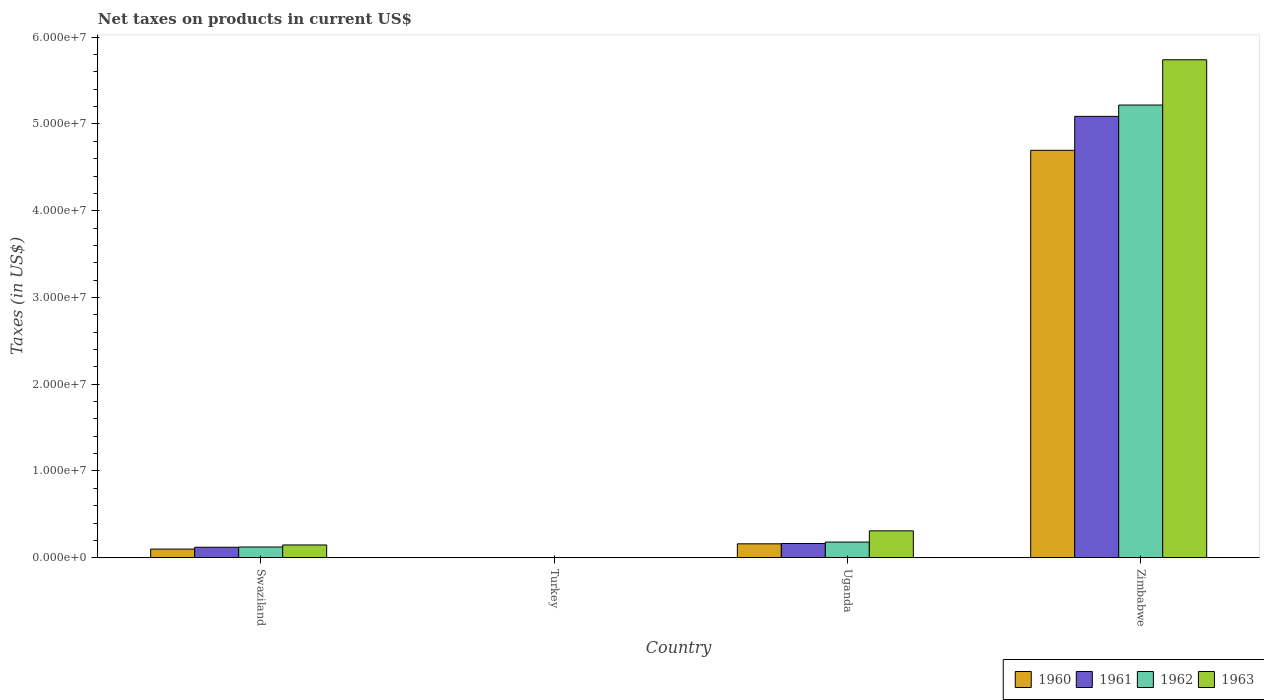How many different coloured bars are there?
Provide a succinct answer. 4. How many bars are there on the 1st tick from the right?
Make the answer very short. 4. What is the label of the 4th group of bars from the left?
Ensure brevity in your answer.  Zimbabwe. What is the net taxes on products in 1960 in Swaziland?
Give a very brief answer. 1.00e+06. Across all countries, what is the maximum net taxes on products in 1961?
Provide a succinct answer. 5.09e+07. Across all countries, what is the minimum net taxes on products in 1962?
Provide a short and direct response. 1600. In which country was the net taxes on products in 1961 maximum?
Give a very brief answer. Zimbabwe. What is the total net taxes on products in 1961 in the graph?
Offer a very short reply. 5.37e+07. What is the difference between the net taxes on products in 1960 in Swaziland and that in Uganda?
Your answer should be compact. -6.03e+05. What is the difference between the net taxes on products in 1962 in Swaziland and the net taxes on products in 1963 in Zimbabwe?
Your answer should be very brief. -5.62e+07. What is the average net taxes on products in 1960 per country?
Offer a terse response. 1.24e+07. What is the difference between the net taxes on products of/in 1960 and net taxes on products of/in 1963 in Zimbabwe?
Your answer should be compact. -1.04e+07. What is the ratio of the net taxes on products in 1961 in Uganda to that in Zimbabwe?
Make the answer very short. 0.03. What is the difference between the highest and the second highest net taxes on products in 1961?
Ensure brevity in your answer.  -4.34e+05. What is the difference between the highest and the lowest net taxes on products in 1960?
Give a very brief answer. 4.70e+07. In how many countries, is the net taxes on products in 1962 greater than the average net taxes on products in 1962 taken over all countries?
Your answer should be compact. 1. Is it the case that in every country, the sum of the net taxes on products in 1962 and net taxes on products in 1961 is greater than the sum of net taxes on products in 1963 and net taxes on products in 1960?
Offer a terse response. No. What does the 4th bar from the left in Turkey represents?
Keep it short and to the point. 1963. Is it the case that in every country, the sum of the net taxes on products in 1963 and net taxes on products in 1962 is greater than the net taxes on products in 1961?
Ensure brevity in your answer.  Yes. How many bars are there?
Provide a short and direct response. 16. How many countries are there in the graph?
Offer a very short reply. 4. What is the difference between two consecutive major ticks on the Y-axis?
Make the answer very short. 1.00e+07. Does the graph contain any zero values?
Your response must be concise. No. How many legend labels are there?
Provide a short and direct response. 4. What is the title of the graph?
Offer a terse response. Net taxes on products in current US$. Does "1997" appear as one of the legend labels in the graph?
Offer a terse response. No. What is the label or title of the Y-axis?
Your answer should be very brief. Taxes (in US$). What is the Taxes (in US$) in 1960 in Swaziland?
Your answer should be very brief. 1.00e+06. What is the Taxes (in US$) in 1961 in Swaziland?
Provide a succinct answer. 1.21e+06. What is the Taxes (in US$) of 1962 in Swaziland?
Your response must be concise. 1.24e+06. What is the Taxes (in US$) in 1963 in Swaziland?
Give a very brief answer. 1.47e+06. What is the Taxes (in US$) in 1960 in Turkey?
Make the answer very short. 1300. What is the Taxes (in US$) of 1961 in Turkey?
Provide a short and direct response. 1500. What is the Taxes (in US$) in 1962 in Turkey?
Provide a short and direct response. 1600. What is the Taxes (in US$) in 1963 in Turkey?
Keep it short and to the point. 1800. What is the Taxes (in US$) in 1960 in Uganda?
Make the answer very short. 1.61e+06. What is the Taxes (in US$) of 1961 in Uganda?
Your answer should be compact. 1.64e+06. What is the Taxes (in US$) in 1962 in Uganda?
Keep it short and to the point. 1.81e+06. What is the Taxes (in US$) in 1963 in Uganda?
Make the answer very short. 3.10e+06. What is the Taxes (in US$) in 1960 in Zimbabwe?
Offer a very short reply. 4.70e+07. What is the Taxes (in US$) of 1961 in Zimbabwe?
Your response must be concise. 5.09e+07. What is the Taxes (in US$) of 1962 in Zimbabwe?
Keep it short and to the point. 5.22e+07. What is the Taxes (in US$) in 1963 in Zimbabwe?
Your response must be concise. 5.74e+07. Across all countries, what is the maximum Taxes (in US$) in 1960?
Your response must be concise. 4.70e+07. Across all countries, what is the maximum Taxes (in US$) in 1961?
Keep it short and to the point. 5.09e+07. Across all countries, what is the maximum Taxes (in US$) in 1962?
Make the answer very short. 5.22e+07. Across all countries, what is the maximum Taxes (in US$) in 1963?
Provide a short and direct response. 5.74e+07. Across all countries, what is the minimum Taxes (in US$) of 1960?
Make the answer very short. 1300. Across all countries, what is the minimum Taxes (in US$) in 1961?
Provide a short and direct response. 1500. Across all countries, what is the minimum Taxes (in US$) of 1962?
Ensure brevity in your answer.  1600. Across all countries, what is the minimum Taxes (in US$) in 1963?
Offer a terse response. 1800. What is the total Taxes (in US$) of 1960 in the graph?
Keep it short and to the point. 4.96e+07. What is the total Taxes (in US$) of 1961 in the graph?
Ensure brevity in your answer.  5.37e+07. What is the total Taxes (in US$) in 1962 in the graph?
Offer a terse response. 5.52e+07. What is the total Taxes (in US$) of 1963 in the graph?
Make the answer very short. 6.20e+07. What is the difference between the Taxes (in US$) of 1960 in Swaziland and that in Turkey?
Give a very brief answer. 1.00e+06. What is the difference between the Taxes (in US$) of 1961 in Swaziland and that in Turkey?
Keep it short and to the point. 1.21e+06. What is the difference between the Taxes (in US$) of 1962 in Swaziland and that in Turkey?
Offer a terse response. 1.24e+06. What is the difference between the Taxes (in US$) in 1963 in Swaziland and that in Turkey?
Provide a short and direct response. 1.47e+06. What is the difference between the Taxes (in US$) of 1960 in Swaziland and that in Uganda?
Your answer should be compact. -6.03e+05. What is the difference between the Taxes (in US$) of 1961 in Swaziland and that in Uganda?
Provide a short and direct response. -4.34e+05. What is the difference between the Taxes (in US$) in 1962 in Swaziland and that in Uganda?
Provide a succinct answer. -5.69e+05. What is the difference between the Taxes (in US$) of 1963 in Swaziland and that in Uganda?
Give a very brief answer. -1.63e+06. What is the difference between the Taxes (in US$) in 1960 in Swaziland and that in Zimbabwe?
Ensure brevity in your answer.  -4.60e+07. What is the difference between the Taxes (in US$) of 1961 in Swaziland and that in Zimbabwe?
Your answer should be compact. -4.97e+07. What is the difference between the Taxes (in US$) of 1962 in Swaziland and that in Zimbabwe?
Your answer should be very brief. -5.09e+07. What is the difference between the Taxes (in US$) in 1963 in Swaziland and that in Zimbabwe?
Give a very brief answer. -5.59e+07. What is the difference between the Taxes (in US$) in 1960 in Turkey and that in Uganda?
Offer a very short reply. -1.60e+06. What is the difference between the Taxes (in US$) in 1961 in Turkey and that in Uganda?
Your answer should be very brief. -1.64e+06. What is the difference between the Taxes (in US$) in 1962 in Turkey and that in Uganda?
Your response must be concise. -1.81e+06. What is the difference between the Taxes (in US$) of 1963 in Turkey and that in Uganda?
Provide a succinct answer. -3.10e+06. What is the difference between the Taxes (in US$) in 1960 in Turkey and that in Zimbabwe?
Provide a succinct answer. -4.70e+07. What is the difference between the Taxes (in US$) of 1961 in Turkey and that in Zimbabwe?
Your answer should be compact. -5.09e+07. What is the difference between the Taxes (in US$) of 1962 in Turkey and that in Zimbabwe?
Your response must be concise. -5.22e+07. What is the difference between the Taxes (in US$) of 1963 in Turkey and that in Zimbabwe?
Give a very brief answer. -5.74e+07. What is the difference between the Taxes (in US$) of 1960 in Uganda and that in Zimbabwe?
Your response must be concise. -4.54e+07. What is the difference between the Taxes (in US$) of 1961 in Uganda and that in Zimbabwe?
Your answer should be compact. -4.92e+07. What is the difference between the Taxes (in US$) in 1962 in Uganda and that in Zimbabwe?
Your response must be concise. -5.04e+07. What is the difference between the Taxes (in US$) of 1963 in Uganda and that in Zimbabwe?
Make the answer very short. -5.43e+07. What is the difference between the Taxes (in US$) of 1960 in Swaziland and the Taxes (in US$) of 1961 in Turkey?
Your answer should be compact. 1.00e+06. What is the difference between the Taxes (in US$) in 1960 in Swaziland and the Taxes (in US$) in 1962 in Turkey?
Provide a succinct answer. 1.00e+06. What is the difference between the Taxes (in US$) in 1960 in Swaziland and the Taxes (in US$) in 1963 in Turkey?
Make the answer very short. 1.00e+06. What is the difference between the Taxes (in US$) of 1961 in Swaziland and the Taxes (in US$) of 1962 in Turkey?
Your response must be concise. 1.21e+06. What is the difference between the Taxes (in US$) of 1961 in Swaziland and the Taxes (in US$) of 1963 in Turkey?
Ensure brevity in your answer.  1.21e+06. What is the difference between the Taxes (in US$) of 1962 in Swaziland and the Taxes (in US$) of 1963 in Turkey?
Your response must be concise. 1.24e+06. What is the difference between the Taxes (in US$) of 1960 in Swaziland and the Taxes (in US$) of 1961 in Uganda?
Provide a succinct answer. -6.40e+05. What is the difference between the Taxes (in US$) of 1960 in Swaziland and the Taxes (in US$) of 1962 in Uganda?
Your answer should be compact. -8.05e+05. What is the difference between the Taxes (in US$) in 1960 in Swaziland and the Taxes (in US$) in 1963 in Uganda?
Provide a succinct answer. -2.10e+06. What is the difference between the Taxes (in US$) in 1961 in Swaziland and the Taxes (in US$) in 1962 in Uganda?
Ensure brevity in your answer.  -5.99e+05. What is the difference between the Taxes (in US$) of 1961 in Swaziland and the Taxes (in US$) of 1963 in Uganda?
Your response must be concise. -1.89e+06. What is the difference between the Taxes (in US$) in 1962 in Swaziland and the Taxes (in US$) in 1963 in Uganda?
Ensure brevity in your answer.  -1.86e+06. What is the difference between the Taxes (in US$) in 1960 in Swaziland and the Taxes (in US$) in 1961 in Zimbabwe?
Your answer should be very brief. -4.99e+07. What is the difference between the Taxes (in US$) in 1960 in Swaziland and the Taxes (in US$) in 1962 in Zimbabwe?
Keep it short and to the point. -5.12e+07. What is the difference between the Taxes (in US$) of 1960 in Swaziland and the Taxes (in US$) of 1963 in Zimbabwe?
Make the answer very short. -5.64e+07. What is the difference between the Taxes (in US$) of 1961 in Swaziland and the Taxes (in US$) of 1962 in Zimbabwe?
Ensure brevity in your answer.  -5.10e+07. What is the difference between the Taxes (in US$) in 1961 in Swaziland and the Taxes (in US$) in 1963 in Zimbabwe?
Your response must be concise. -5.62e+07. What is the difference between the Taxes (in US$) in 1962 in Swaziland and the Taxes (in US$) in 1963 in Zimbabwe?
Ensure brevity in your answer.  -5.62e+07. What is the difference between the Taxes (in US$) of 1960 in Turkey and the Taxes (in US$) of 1961 in Uganda?
Give a very brief answer. -1.64e+06. What is the difference between the Taxes (in US$) of 1960 in Turkey and the Taxes (in US$) of 1962 in Uganda?
Your response must be concise. -1.81e+06. What is the difference between the Taxes (in US$) in 1960 in Turkey and the Taxes (in US$) in 1963 in Uganda?
Give a very brief answer. -3.10e+06. What is the difference between the Taxes (in US$) of 1961 in Turkey and the Taxes (in US$) of 1962 in Uganda?
Offer a terse response. -1.81e+06. What is the difference between the Taxes (in US$) of 1961 in Turkey and the Taxes (in US$) of 1963 in Uganda?
Your answer should be very brief. -3.10e+06. What is the difference between the Taxes (in US$) in 1962 in Turkey and the Taxes (in US$) in 1963 in Uganda?
Provide a succinct answer. -3.10e+06. What is the difference between the Taxes (in US$) of 1960 in Turkey and the Taxes (in US$) of 1961 in Zimbabwe?
Make the answer very short. -5.09e+07. What is the difference between the Taxes (in US$) of 1960 in Turkey and the Taxes (in US$) of 1962 in Zimbabwe?
Make the answer very short. -5.22e+07. What is the difference between the Taxes (in US$) of 1960 in Turkey and the Taxes (in US$) of 1963 in Zimbabwe?
Make the answer very short. -5.74e+07. What is the difference between the Taxes (in US$) of 1961 in Turkey and the Taxes (in US$) of 1962 in Zimbabwe?
Your answer should be very brief. -5.22e+07. What is the difference between the Taxes (in US$) of 1961 in Turkey and the Taxes (in US$) of 1963 in Zimbabwe?
Offer a terse response. -5.74e+07. What is the difference between the Taxes (in US$) in 1962 in Turkey and the Taxes (in US$) in 1963 in Zimbabwe?
Provide a short and direct response. -5.74e+07. What is the difference between the Taxes (in US$) of 1960 in Uganda and the Taxes (in US$) of 1961 in Zimbabwe?
Your response must be concise. -4.93e+07. What is the difference between the Taxes (in US$) in 1960 in Uganda and the Taxes (in US$) in 1962 in Zimbabwe?
Make the answer very short. -5.06e+07. What is the difference between the Taxes (in US$) of 1960 in Uganda and the Taxes (in US$) of 1963 in Zimbabwe?
Your answer should be very brief. -5.58e+07. What is the difference between the Taxes (in US$) in 1961 in Uganda and the Taxes (in US$) in 1962 in Zimbabwe?
Keep it short and to the point. -5.05e+07. What is the difference between the Taxes (in US$) in 1961 in Uganda and the Taxes (in US$) in 1963 in Zimbabwe?
Ensure brevity in your answer.  -5.58e+07. What is the difference between the Taxes (in US$) of 1962 in Uganda and the Taxes (in US$) of 1963 in Zimbabwe?
Provide a short and direct response. -5.56e+07. What is the average Taxes (in US$) in 1960 per country?
Give a very brief answer. 1.24e+07. What is the average Taxes (in US$) of 1961 per country?
Offer a terse response. 1.34e+07. What is the average Taxes (in US$) in 1962 per country?
Offer a terse response. 1.38e+07. What is the average Taxes (in US$) in 1963 per country?
Keep it short and to the point. 1.55e+07. What is the difference between the Taxes (in US$) in 1960 and Taxes (in US$) in 1961 in Swaziland?
Your response must be concise. -2.06e+05. What is the difference between the Taxes (in US$) in 1960 and Taxes (in US$) in 1962 in Swaziland?
Provide a succinct answer. -2.36e+05. What is the difference between the Taxes (in US$) of 1960 and Taxes (in US$) of 1963 in Swaziland?
Offer a very short reply. -4.72e+05. What is the difference between the Taxes (in US$) in 1961 and Taxes (in US$) in 1962 in Swaziland?
Offer a very short reply. -2.95e+04. What is the difference between the Taxes (in US$) of 1961 and Taxes (in US$) of 1963 in Swaziland?
Your answer should be compact. -2.65e+05. What is the difference between the Taxes (in US$) of 1962 and Taxes (in US$) of 1963 in Swaziland?
Make the answer very short. -2.36e+05. What is the difference between the Taxes (in US$) in 1960 and Taxes (in US$) in 1961 in Turkey?
Offer a terse response. -200. What is the difference between the Taxes (in US$) in 1960 and Taxes (in US$) in 1962 in Turkey?
Your answer should be compact. -300. What is the difference between the Taxes (in US$) of 1960 and Taxes (in US$) of 1963 in Turkey?
Offer a very short reply. -500. What is the difference between the Taxes (in US$) of 1961 and Taxes (in US$) of 1962 in Turkey?
Provide a short and direct response. -100. What is the difference between the Taxes (in US$) in 1961 and Taxes (in US$) in 1963 in Turkey?
Your response must be concise. -300. What is the difference between the Taxes (in US$) in 1962 and Taxes (in US$) in 1963 in Turkey?
Provide a succinct answer. -200. What is the difference between the Taxes (in US$) in 1960 and Taxes (in US$) in 1961 in Uganda?
Ensure brevity in your answer.  -3.67e+04. What is the difference between the Taxes (in US$) of 1960 and Taxes (in US$) of 1962 in Uganda?
Give a very brief answer. -2.02e+05. What is the difference between the Taxes (in US$) of 1960 and Taxes (in US$) of 1963 in Uganda?
Provide a short and direct response. -1.50e+06. What is the difference between the Taxes (in US$) of 1961 and Taxes (in US$) of 1962 in Uganda?
Your response must be concise. -1.65e+05. What is the difference between the Taxes (in US$) of 1961 and Taxes (in US$) of 1963 in Uganda?
Provide a succinct answer. -1.46e+06. What is the difference between the Taxes (in US$) in 1962 and Taxes (in US$) in 1963 in Uganda?
Your answer should be compact. -1.29e+06. What is the difference between the Taxes (in US$) of 1960 and Taxes (in US$) of 1961 in Zimbabwe?
Provide a succinct answer. -3.91e+06. What is the difference between the Taxes (in US$) in 1960 and Taxes (in US$) in 1962 in Zimbabwe?
Provide a succinct answer. -5.22e+06. What is the difference between the Taxes (in US$) of 1960 and Taxes (in US$) of 1963 in Zimbabwe?
Ensure brevity in your answer.  -1.04e+07. What is the difference between the Taxes (in US$) of 1961 and Taxes (in US$) of 1962 in Zimbabwe?
Provide a short and direct response. -1.30e+06. What is the difference between the Taxes (in US$) in 1961 and Taxes (in US$) in 1963 in Zimbabwe?
Your response must be concise. -6.52e+06. What is the difference between the Taxes (in US$) in 1962 and Taxes (in US$) in 1963 in Zimbabwe?
Your answer should be compact. -5.22e+06. What is the ratio of the Taxes (in US$) of 1960 in Swaziland to that in Turkey?
Give a very brief answer. 771.23. What is the ratio of the Taxes (in US$) of 1961 in Swaziland to that in Turkey?
Your answer should be compact. 806. What is the ratio of the Taxes (in US$) of 1962 in Swaziland to that in Turkey?
Provide a short and direct response. 774.06. What is the ratio of the Taxes (in US$) of 1963 in Swaziland to that in Turkey?
Your answer should be very brief. 819.11. What is the ratio of the Taxes (in US$) of 1960 in Swaziland to that in Uganda?
Ensure brevity in your answer.  0.62. What is the ratio of the Taxes (in US$) in 1961 in Swaziland to that in Uganda?
Give a very brief answer. 0.74. What is the ratio of the Taxes (in US$) in 1962 in Swaziland to that in Uganda?
Your answer should be compact. 0.69. What is the ratio of the Taxes (in US$) in 1963 in Swaziland to that in Uganda?
Offer a terse response. 0.48. What is the ratio of the Taxes (in US$) of 1960 in Swaziland to that in Zimbabwe?
Ensure brevity in your answer.  0.02. What is the ratio of the Taxes (in US$) of 1961 in Swaziland to that in Zimbabwe?
Your response must be concise. 0.02. What is the ratio of the Taxes (in US$) in 1962 in Swaziland to that in Zimbabwe?
Provide a succinct answer. 0.02. What is the ratio of the Taxes (in US$) in 1963 in Swaziland to that in Zimbabwe?
Provide a short and direct response. 0.03. What is the ratio of the Taxes (in US$) in 1960 in Turkey to that in Uganda?
Ensure brevity in your answer.  0. What is the ratio of the Taxes (in US$) in 1961 in Turkey to that in Uganda?
Your answer should be very brief. 0. What is the ratio of the Taxes (in US$) in 1962 in Turkey to that in Uganda?
Offer a terse response. 0. What is the ratio of the Taxes (in US$) of 1963 in Turkey to that in Uganda?
Keep it short and to the point. 0. What is the ratio of the Taxes (in US$) in 1962 in Turkey to that in Zimbabwe?
Your response must be concise. 0. What is the ratio of the Taxes (in US$) in 1963 in Turkey to that in Zimbabwe?
Your response must be concise. 0. What is the ratio of the Taxes (in US$) in 1960 in Uganda to that in Zimbabwe?
Keep it short and to the point. 0.03. What is the ratio of the Taxes (in US$) of 1961 in Uganda to that in Zimbabwe?
Provide a short and direct response. 0.03. What is the ratio of the Taxes (in US$) in 1962 in Uganda to that in Zimbabwe?
Your answer should be compact. 0.03. What is the ratio of the Taxes (in US$) of 1963 in Uganda to that in Zimbabwe?
Provide a succinct answer. 0.05. What is the difference between the highest and the second highest Taxes (in US$) in 1960?
Your answer should be very brief. 4.54e+07. What is the difference between the highest and the second highest Taxes (in US$) of 1961?
Your answer should be very brief. 4.92e+07. What is the difference between the highest and the second highest Taxes (in US$) in 1962?
Offer a very short reply. 5.04e+07. What is the difference between the highest and the second highest Taxes (in US$) in 1963?
Make the answer very short. 5.43e+07. What is the difference between the highest and the lowest Taxes (in US$) in 1960?
Provide a short and direct response. 4.70e+07. What is the difference between the highest and the lowest Taxes (in US$) in 1961?
Ensure brevity in your answer.  5.09e+07. What is the difference between the highest and the lowest Taxes (in US$) of 1962?
Keep it short and to the point. 5.22e+07. What is the difference between the highest and the lowest Taxes (in US$) of 1963?
Provide a succinct answer. 5.74e+07. 